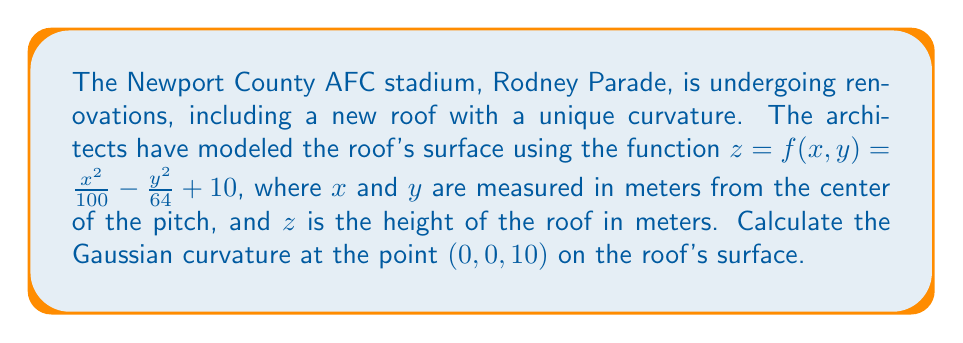Can you answer this question? To find the Gaussian curvature at a point on a surface defined by $z = f(x,y)$, we need to follow these steps:

1) First, we need to calculate the partial derivatives:

   $f_x = \frac{\partial f}{\partial x} = \frac{2x}{100}$
   $f_y = \frac{\partial f}{\partial y} = -\frac{y}{32}$
   $f_{xx} = \frac{\partial^2 f}{\partial x^2} = \frac{1}{50}$
   $f_{yy} = \frac{\partial^2 f}{\partial y^2} = -\frac{1}{32}$
   $f_{xy} = f_{yx} = \frac{\partial^2 f}{\partial x \partial y} = 0$

2) Next, we calculate the coefficients of the first fundamental form:

   $E = 1 + f_x^2 = 1 + (\frac{2x}{100})^2$
   $F = f_x f_y = (\frac{2x}{100})(-\frac{y}{32})$
   $G = 1 + f_y^2 = 1 + (-\frac{y}{32})^2$

3) Then, we calculate the coefficients of the second fundamental form:

   $e = \frac{f_{xx}}{\sqrt{1 + f_x^2 + f_y^2}} = \frac{\frac{1}{50}}{\sqrt{1 + (\frac{2x}{100})^2 + (-\frac{y}{32})^2}}$
   
   $f = \frac{f_{xy}}{\sqrt{1 + f_x^2 + f_y^2}} = 0$
   
   $g = \frac{f_{yy}}{\sqrt{1 + f_x^2 + f_y^2}} = \frac{-\frac{1}{32}}{\sqrt{1 + (\frac{2x}{100})^2 + (-\frac{y}{32})^2}}$

4) The Gaussian curvature is given by:

   $K = \frac{eg - f^2}{EG - F^2}$

5) At the point (0, 0, 10):

   $E = 1$, $F = 0$, $G = 1$
   $e = \frac{1}{50}$, $f = 0$, $g = -\frac{1}{32}$

6) Substituting these values:

   $K = \frac{(\frac{1}{50})(-\frac{1}{32}) - 0^2}{(1)(1) - 0^2} = -\frac{1}{1600}$

Therefore, the Gaussian curvature at the point (0, 0, 10) is $-\frac{1}{1600}$.
Answer: $$K = -\frac{1}{1600}$$ 